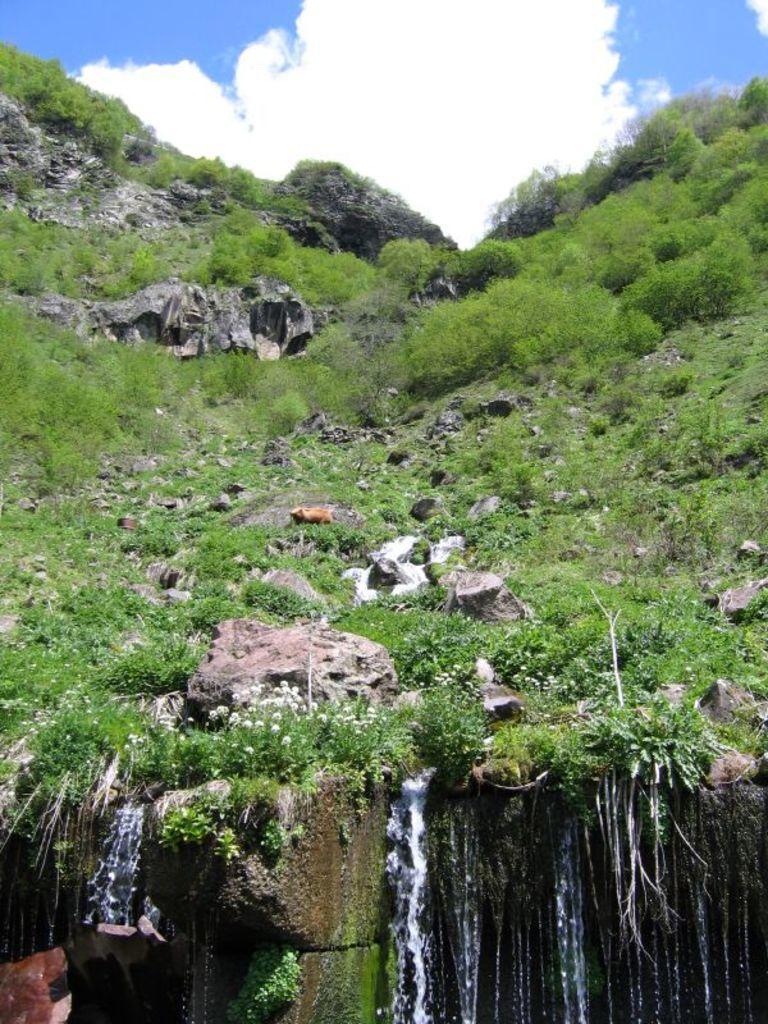Describe this image in one or two sentences. In this image we can see rocks, grass and other objects. At the bottom of the image there is a waterfall. At the top of the image there is the sky. 